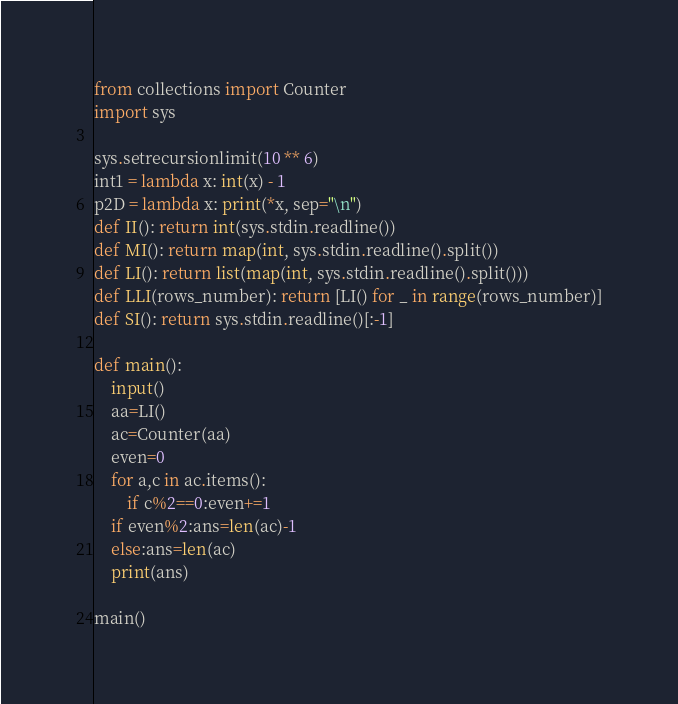Convert code to text. <code><loc_0><loc_0><loc_500><loc_500><_Python_>from collections import Counter
import sys

sys.setrecursionlimit(10 ** 6)
int1 = lambda x: int(x) - 1
p2D = lambda x: print(*x, sep="\n")
def II(): return int(sys.stdin.readline())
def MI(): return map(int, sys.stdin.readline().split())
def LI(): return list(map(int, sys.stdin.readline().split()))
def LLI(rows_number): return [LI() for _ in range(rows_number)]
def SI(): return sys.stdin.readline()[:-1]

def main():
    input()
    aa=LI()
    ac=Counter(aa)
    even=0
    for a,c in ac.items():
        if c%2==0:even+=1
    if even%2:ans=len(ac)-1
    else:ans=len(ac)
    print(ans)

main()</code> 